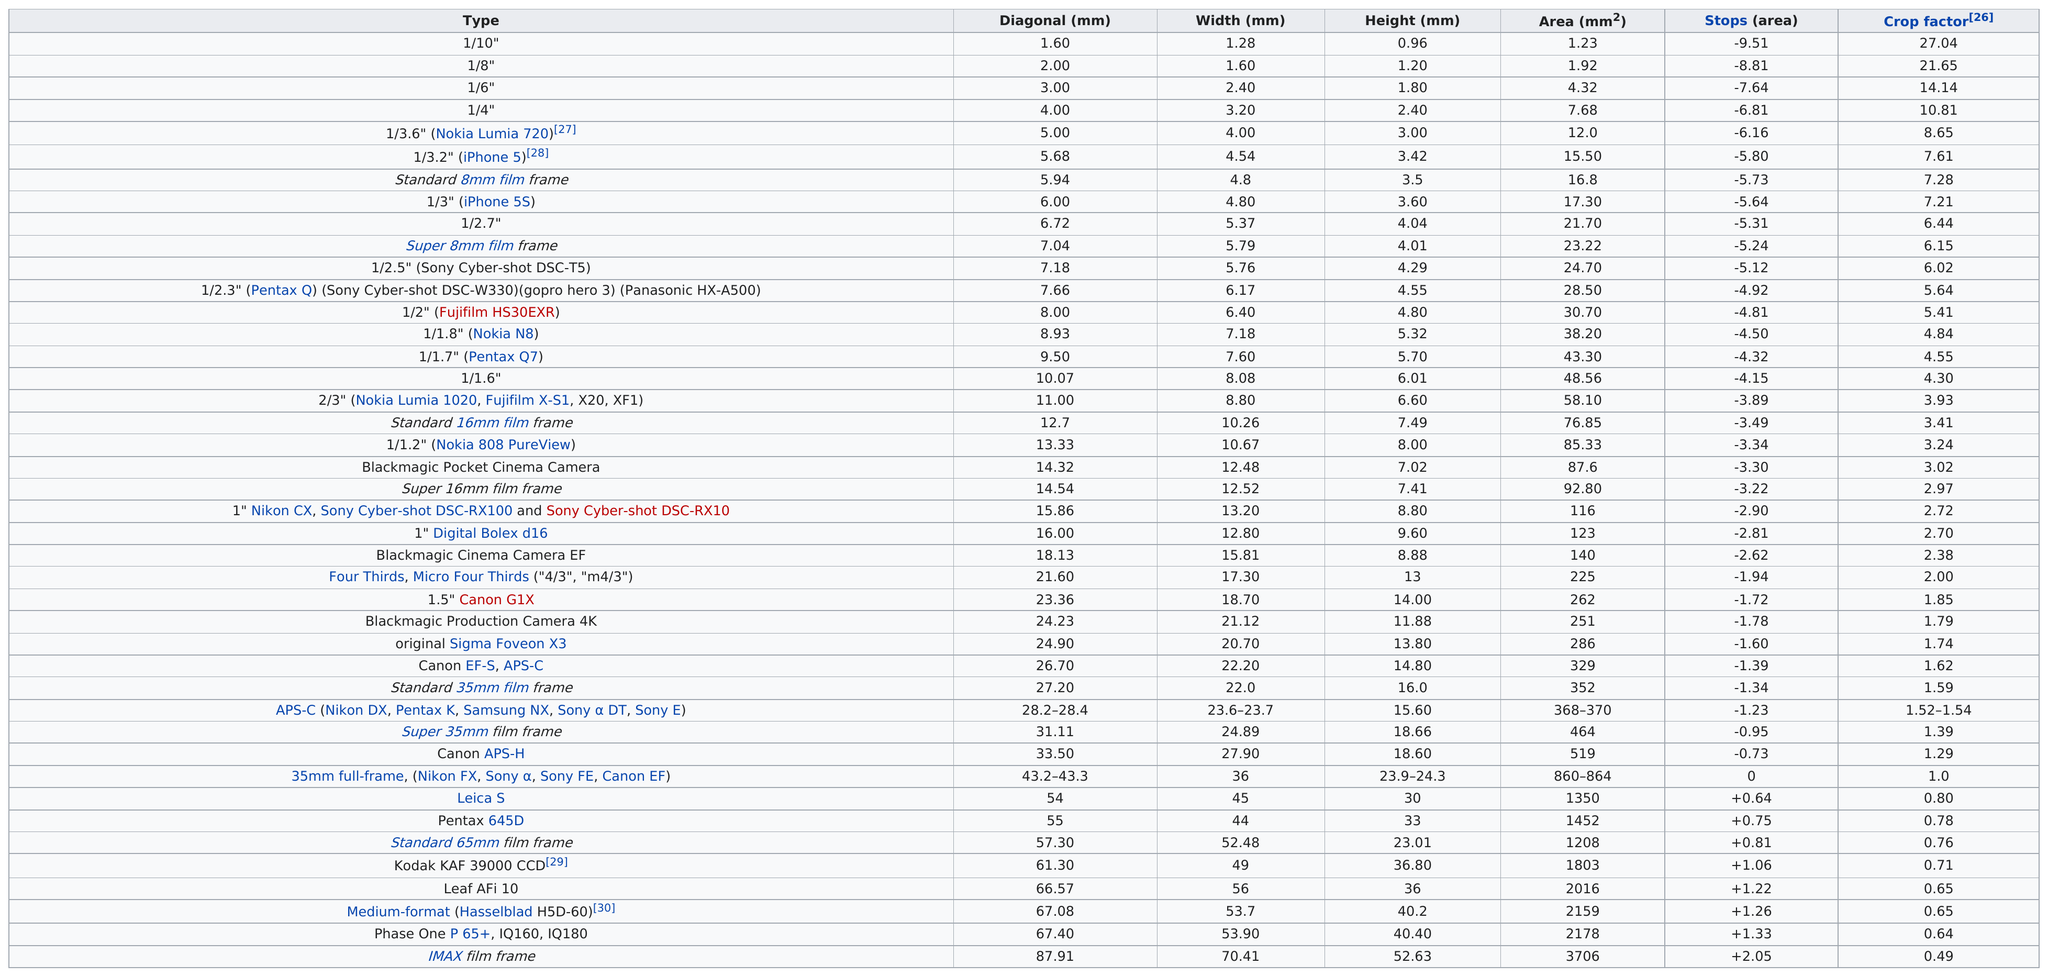Highlight a few significant elements in this photo. Which image frame has the largest crop factor? 1/10" refers to a question asking for the frame with the highest crop factor from a set of images. It is certain that no image frame has the same height as the Nokia Lumia 720. There is a difference of 0.69 units in the area between the 1/10 and the 1/8 ratio. The diagonal size of a 1/10 sensor is approximately 1.6 inches. The two lens types with a crop factor over 20 are 1/10 and 1/8. 